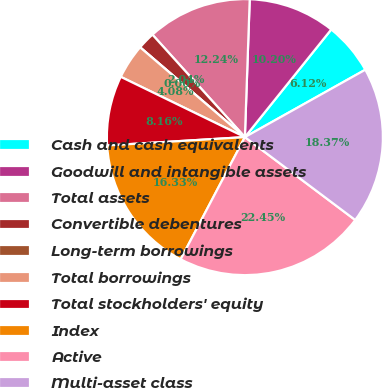Convert chart to OTSL. <chart><loc_0><loc_0><loc_500><loc_500><pie_chart><fcel>Cash and cash equivalents<fcel>Goodwill and intangible assets<fcel>Total assets<fcel>Convertible debentures<fcel>Long-term borrowings<fcel>Total borrowings<fcel>Total stockholders' equity<fcel>Index<fcel>Active<fcel>Multi-asset class<nl><fcel>6.12%<fcel>10.2%<fcel>12.24%<fcel>2.04%<fcel>0.0%<fcel>4.08%<fcel>8.16%<fcel>16.33%<fcel>22.45%<fcel>18.37%<nl></chart> 